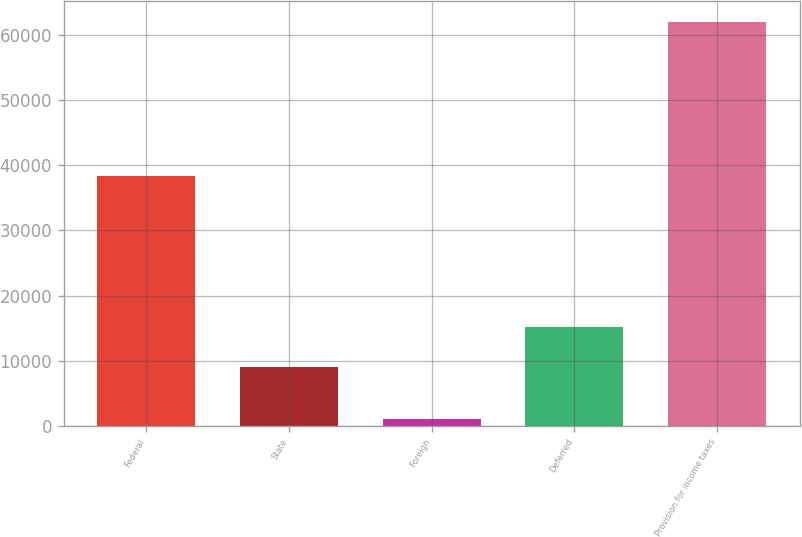<chart> <loc_0><loc_0><loc_500><loc_500><bar_chart><fcel>Federal<fcel>State<fcel>Foreign<fcel>Deferred<fcel>Provision for income taxes<nl><fcel>38294<fcel>9099<fcel>1113<fcel>15191.8<fcel>62041<nl></chart> 